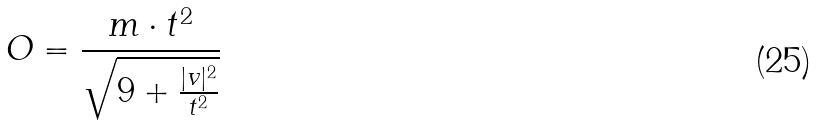Convert formula to latex. <formula><loc_0><loc_0><loc_500><loc_500>O = \frac { m \cdot t ^ { 2 } } { \sqrt { 9 + \frac { | v | ^ { 2 } } { t ^ { 2 } } } }</formula> 